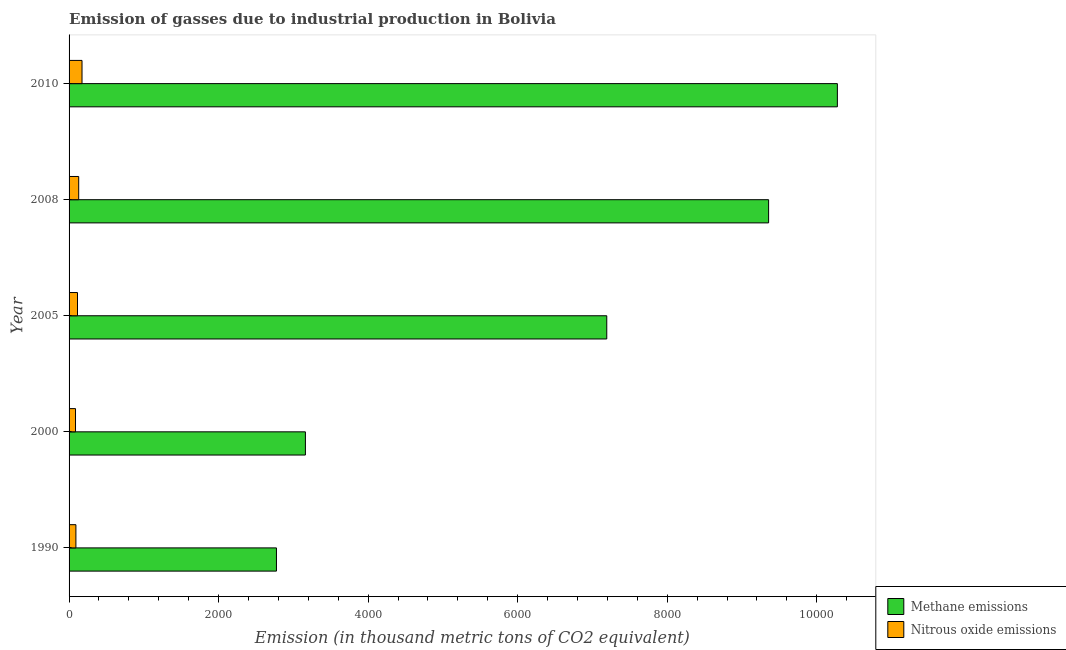How many different coloured bars are there?
Offer a terse response. 2. Are the number of bars per tick equal to the number of legend labels?
Provide a succinct answer. Yes. How many bars are there on the 5th tick from the top?
Offer a terse response. 2. What is the amount of methane emissions in 1990?
Make the answer very short. 2773.8. Across all years, what is the maximum amount of methane emissions?
Provide a short and direct response. 1.03e+04. Across all years, what is the minimum amount of methane emissions?
Provide a short and direct response. 2773.8. What is the total amount of methane emissions in the graph?
Ensure brevity in your answer.  3.28e+04. What is the difference between the amount of methane emissions in 1990 and that in 2000?
Your answer should be compact. -387.1. What is the difference between the amount of methane emissions in 2008 and the amount of nitrous oxide emissions in 2010?
Your answer should be compact. 9183.1. What is the average amount of nitrous oxide emissions per year?
Provide a short and direct response. 118.5. In the year 1990, what is the difference between the amount of nitrous oxide emissions and amount of methane emissions?
Offer a very short reply. -2682.4. In how many years, is the amount of nitrous oxide emissions greater than 2000 thousand metric tons?
Your response must be concise. 0. What is the ratio of the amount of nitrous oxide emissions in 2000 to that in 2008?
Provide a succinct answer. 0.67. Is the amount of methane emissions in 2000 less than that in 2008?
Your response must be concise. Yes. Is the difference between the amount of nitrous oxide emissions in 1990 and 2008 greater than the difference between the amount of methane emissions in 1990 and 2008?
Offer a terse response. Yes. What is the difference between the highest and the second highest amount of nitrous oxide emissions?
Keep it short and to the point. 44.3. What is the difference between the highest and the lowest amount of nitrous oxide emissions?
Provide a succinct answer. 86.9. In how many years, is the amount of methane emissions greater than the average amount of methane emissions taken over all years?
Keep it short and to the point. 3. Is the sum of the amount of nitrous oxide emissions in 2000 and 2010 greater than the maximum amount of methane emissions across all years?
Give a very brief answer. No. What does the 1st bar from the top in 2008 represents?
Your answer should be compact. Nitrous oxide emissions. What does the 1st bar from the bottom in 1990 represents?
Your answer should be compact. Methane emissions. How many bars are there?
Provide a succinct answer. 10. Are the values on the major ticks of X-axis written in scientific E-notation?
Keep it short and to the point. No. How many legend labels are there?
Your answer should be very brief. 2. How are the legend labels stacked?
Your answer should be very brief. Vertical. What is the title of the graph?
Your response must be concise. Emission of gasses due to industrial production in Bolivia. What is the label or title of the X-axis?
Make the answer very short. Emission (in thousand metric tons of CO2 equivalent). What is the Emission (in thousand metric tons of CO2 equivalent) in Methane emissions in 1990?
Ensure brevity in your answer.  2773.8. What is the Emission (in thousand metric tons of CO2 equivalent) in Nitrous oxide emissions in 1990?
Give a very brief answer. 91.4. What is the Emission (in thousand metric tons of CO2 equivalent) in Methane emissions in 2000?
Give a very brief answer. 3160.9. What is the Emission (in thousand metric tons of CO2 equivalent) in Nitrous oxide emissions in 2000?
Provide a succinct answer. 86.3. What is the Emission (in thousand metric tons of CO2 equivalent) in Methane emissions in 2005?
Offer a very short reply. 7191.7. What is the Emission (in thousand metric tons of CO2 equivalent) of Nitrous oxide emissions in 2005?
Provide a short and direct response. 112.7. What is the Emission (in thousand metric tons of CO2 equivalent) of Methane emissions in 2008?
Provide a short and direct response. 9356.3. What is the Emission (in thousand metric tons of CO2 equivalent) in Nitrous oxide emissions in 2008?
Give a very brief answer. 128.9. What is the Emission (in thousand metric tons of CO2 equivalent) in Methane emissions in 2010?
Provide a short and direct response. 1.03e+04. What is the Emission (in thousand metric tons of CO2 equivalent) in Nitrous oxide emissions in 2010?
Offer a terse response. 173.2. Across all years, what is the maximum Emission (in thousand metric tons of CO2 equivalent) in Methane emissions?
Keep it short and to the point. 1.03e+04. Across all years, what is the maximum Emission (in thousand metric tons of CO2 equivalent) in Nitrous oxide emissions?
Ensure brevity in your answer.  173.2. Across all years, what is the minimum Emission (in thousand metric tons of CO2 equivalent) in Methane emissions?
Ensure brevity in your answer.  2773.8. Across all years, what is the minimum Emission (in thousand metric tons of CO2 equivalent) in Nitrous oxide emissions?
Provide a succinct answer. 86.3. What is the total Emission (in thousand metric tons of CO2 equivalent) of Methane emissions in the graph?
Ensure brevity in your answer.  3.28e+04. What is the total Emission (in thousand metric tons of CO2 equivalent) of Nitrous oxide emissions in the graph?
Provide a short and direct response. 592.5. What is the difference between the Emission (in thousand metric tons of CO2 equivalent) of Methane emissions in 1990 and that in 2000?
Make the answer very short. -387.1. What is the difference between the Emission (in thousand metric tons of CO2 equivalent) in Methane emissions in 1990 and that in 2005?
Your answer should be compact. -4417.9. What is the difference between the Emission (in thousand metric tons of CO2 equivalent) in Nitrous oxide emissions in 1990 and that in 2005?
Make the answer very short. -21.3. What is the difference between the Emission (in thousand metric tons of CO2 equivalent) in Methane emissions in 1990 and that in 2008?
Provide a succinct answer. -6582.5. What is the difference between the Emission (in thousand metric tons of CO2 equivalent) in Nitrous oxide emissions in 1990 and that in 2008?
Give a very brief answer. -37.5. What is the difference between the Emission (in thousand metric tons of CO2 equivalent) in Methane emissions in 1990 and that in 2010?
Offer a very short reply. -7502.2. What is the difference between the Emission (in thousand metric tons of CO2 equivalent) of Nitrous oxide emissions in 1990 and that in 2010?
Ensure brevity in your answer.  -81.8. What is the difference between the Emission (in thousand metric tons of CO2 equivalent) in Methane emissions in 2000 and that in 2005?
Offer a terse response. -4030.8. What is the difference between the Emission (in thousand metric tons of CO2 equivalent) in Nitrous oxide emissions in 2000 and that in 2005?
Provide a succinct answer. -26.4. What is the difference between the Emission (in thousand metric tons of CO2 equivalent) of Methane emissions in 2000 and that in 2008?
Make the answer very short. -6195.4. What is the difference between the Emission (in thousand metric tons of CO2 equivalent) of Nitrous oxide emissions in 2000 and that in 2008?
Make the answer very short. -42.6. What is the difference between the Emission (in thousand metric tons of CO2 equivalent) in Methane emissions in 2000 and that in 2010?
Offer a terse response. -7115.1. What is the difference between the Emission (in thousand metric tons of CO2 equivalent) of Nitrous oxide emissions in 2000 and that in 2010?
Make the answer very short. -86.9. What is the difference between the Emission (in thousand metric tons of CO2 equivalent) of Methane emissions in 2005 and that in 2008?
Your response must be concise. -2164.6. What is the difference between the Emission (in thousand metric tons of CO2 equivalent) of Nitrous oxide emissions in 2005 and that in 2008?
Your answer should be very brief. -16.2. What is the difference between the Emission (in thousand metric tons of CO2 equivalent) of Methane emissions in 2005 and that in 2010?
Your answer should be compact. -3084.3. What is the difference between the Emission (in thousand metric tons of CO2 equivalent) of Nitrous oxide emissions in 2005 and that in 2010?
Offer a very short reply. -60.5. What is the difference between the Emission (in thousand metric tons of CO2 equivalent) in Methane emissions in 2008 and that in 2010?
Ensure brevity in your answer.  -919.7. What is the difference between the Emission (in thousand metric tons of CO2 equivalent) of Nitrous oxide emissions in 2008 and that in 2010?
Ensure brevity in your answer.  -44.3. What is the difference between the Emission (in thousand metric tons of CO2 equivalent) in Methane emissions in 1990 and the Emission (in thousand metric tons of CO2 equivalent) in Nitrous oxide emissions in 2000?
Make the answer very short. 2687.5. What is the difference between the Emission (in thousand metric tons of CO2 equivalent) in Methane emissions in 1990 and the Emission (in thousand metric tons of CO2 equivalent) in Nitrous oxide emissions in 2005?
Your answer should be very brief. 2661.1. What is the difference between the Emission (in thousand metric tons of CO2 equivalent) of Methane emissions in 1990 and the Emission (in thousand metric tons of CO2 equivalent) of Nitrous oxide emissions in 2008?
Your answer should be very brief. 2644.9. What is the difference between the Emission (in thousand metric tons of CO2 equivalent) of Methane emissions in 1990 and the Emission (in thousand metric tons of CO2 equivalent) of Nitrous oxide emissions in 2010?
Your answer should be compact. 2600.6. What is the difference between the Emission (in thousand metric tons of CO2 equivalent) in Methane emissions in 2000 and the Emission (in thousand metric tons of CO2 equivalent) in Nitrous oxide emissions in 2005?
Your answer should be very brief. 3048.2. What is the difference between the Emission (in thousand metric tons of CO2 equivalent) of Methane emissions in 2000 and the Emission (in thousand metric tons of CO2 equivalent) of Nitrous oxide emissions in 2008?
Give a very brief answer. 3032. What is the difference between the Emission (in thousand metric tons of CO2 equivalent) of Methane emissions in 2000 and the Emission (in thousand metric tons of CO2 equivalent) of Nitrous oxide emissions in 2010?
Your answer should be very brief. 2987.7. What is the difference between the Emission (in thousand metric tons of CO2 equivalent) of Methane emissions in 2005 and the Emission (in thousand metric tons of CO2 equivalent) of Nitrous oxide emissions in 2008?
Your response must be concise. 7062.8. What is the difference between the Emission (in thousand metric tons of CO2 equivalent) of Methane emissions in 2005 and the Emission (in thousand metric tons of CO2 equivalent) of Nitrous oxide emissions in 2010?
Provide a succinct answer. 7018.5. What is the difference between the Emission (in thousand metric tons of CO2 equivalent) of Methane emissions in 2008 and the Emission (in thousand metric tons of CO2 equivalent) of Nitrous oxide emissions in 2010?
Provide a short and direct response. 9183.1. What is the average Emission (in thousand metric tons of CO2 equivalent) of Methane emissions per year?
Provide a succinct answer. 6551.74. What is the average Emission (in thousand metric tons of CO2 equivalent) in Nitrous oxide emissions per year?
Provide a succinct answer. 118.5. In the year 1990, what is the difference between the Emission (in thousand metric tons of CO2 equivalent) in Methane emissions and Emission (in thousand metric tons of CO2 equivalent) in Nitrous oxide emissions?
Your answer should be compact. 2682.4. In the year 2000, what is the difference between the Emission (in thousand metric tons of CO2 equivalent) of Methane emissions and Emission (in thousand metric tons of CO2 equivalent) of Nitrous oxide emissions?
Ensure brevity in your answer.  3074.6. In the year 2005, what is the difference between the Emission (in thousand metric tons of CO2 equivalent) of Methane emissions and Emission (in thousand metric tons of CO2 equivalent) of Nitrous oxide emissions?
Provide a short and direct response. 7079. In the year 2008, what is the difference between the Emission (in thousand metric tons of CO2 equivalent) of Methane emissions and Emission (in thousand metric tons of CO2 equivalent) of Nitrous oxide emissions?
Offer a very short reply. 9227.4. In the year 2010, what is the difference between the Emission (in thousand metric tons of CO2 equivalent) in Methane emissions and Emission (in thousand metric tons of CO2 equivalent) in Nitrous oxide emissions?
Make the answer very short. 1.01e+04. What is the ratio of the Emission (in thousand metric tons of CO2 equivalent) of Methane emissions in 1990 to that in 2000?
Your answer should be very brief. 0.88. What is the ratio of the Emission (in thousand metric tons of CO2 equivalent) in Nitrous oxide emissions in 1990 to that in 2000?
Give a very brief answer. 1.06. What is the ratio of the Emission (in thousand metric tons of CO2 equivalent) in Methane emissions in 1990 to that in 2005?
Your response must be concise. 0.39. What is the ratio of the Emission (in thousand metric tons of CO2 equivalent) in Nitrous oxide emissions in 1990 to that in 2005?
Your answer should be very brief. 0.81. What is the ratio of the Emission (in thousand metric tons of CO2 equivalent) in Methane emissions in 1990 to that in 2008?
Offer a terse response. 0.3. What is the ratio of the Emission (in thousand metric tons of CO2 equivalent) of Nitrous oxide emissions in 1990 to that in 2008?
Your answer should be compact. 0.71. What is the ratio of the Emission (in thousand metric tons of CO2 equivalent) in Methane emissions in 1990 to that in 2010?
Provide a succinct answer. 0.27. What is the ratio of the Emission (in thousand metric tons of CO2 equivalent) in Nitrous oxide emissions in 1990 to that in 2010?
Provide a short and direct response. 0.53. What is the ratio of the Emission (in thousand metric tons of CO2 equivalent) in Methane emissions in 2000 to that in 2005?
Give a very brief answer. 0.44. What is the ratio of the Emission (in thousand metric tons of CO2 equivalent) in Nitrous oxide emissions in 2000 to that in 2005?
Offer a very short reply. 0.77. What is the ratio of the Emission (in thousand metric tons of CO2 equivalent) of Methane emissions in 2000 to that in 2008?
Make the answer very short. 0.34. What is the ratio of the Emission (in thousand metric tons of CO2 equivalent) in Nitrous oxide emissions in 2000 to that in 2008?
Ensure brevity in your answer.  0.67. What is the ratio of the Emission (in thousand metric tons of CO2 equivalent) in Methane emissions in 2000 to that in 2010?
Your answer should be very brief. 0.31. What is the ratio of the Emission (in thousand metric tons of CO2 equivalent) of Nitrous oxide emissions in 2000 to that in 2010?
Your response must be concise. 0.5. What is the ratio of the Emission (in thousand metric tons of CO2 equivalent) of Methane emissions in 2005 to that in 2008?
Make the answer very short. 0.77. What is the ratio of the Emission (in thousand metric tons of CO2 equivalent) in Nitrous oxide emissions in 2005 to that in 2008?
Ensure brevity in your answer.  0.87. What is the ratio of the Emission (in thousand metric tons of CO2 equivalent) of Methane emissions in 2005 to that in 2010?
Provide a succinct answer. 0.7. What is the ratio of the Emission (in thousand metric tons of CO2 equivalent) of Nitrous oxide emissions in 2005 to that in 2010?
Your response must be concise. 0.65. What is the ratio of the Emission (in thousand metric tons of CO2 equivalent) of Methane emissions in 2008 to that in 2010?
Give a very brief answer. 0.91. What is the ratio of the Emission (in thousand metric tons of CO2 equivalent) of Nitrous oxide emissions in 2008 to that in 2010?
Offer a terse response. 0.74. What is the difference between the highest and the second highest Emission (in thousand metric tons of CO2 equivalent) in Methane emissions?
Make the answer very short. 919.7. What is the difference between the highest and the second highest Emission (in thousand metric tons of CO2 equivalent) of Nitrous oxide emissions?
Offer a very short reply. 44.3. What is the difference between the highest and the lowest Emission (in thousand metric tons of CO2 equivalent) of Methane emissions?
Offer a very short reply. 7502.2. What is the difference between the highest and the lowest Emission (in thousand metric tons of CO2 equivalent) in Nitrous oxide emissions?
Ensure brevity in your answer.  86.9. 